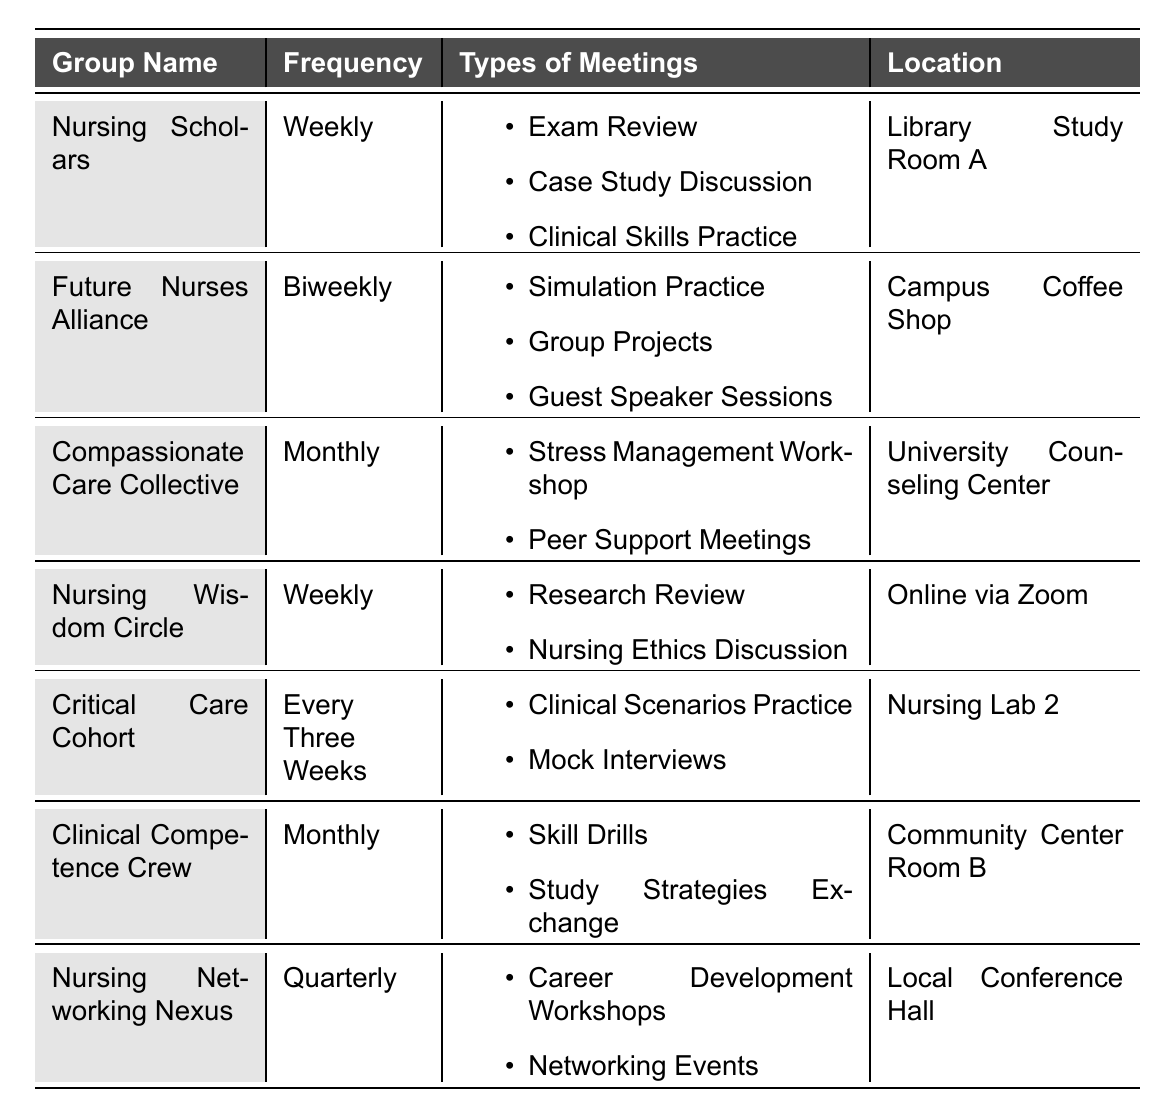What is the location of the Nursing Scholars group? The table lists "Library Study Room A" as the location for the Nursing Scholars group under the "Location" column.
Answer: Library Study Room A How often does the Clinical Competence Crew meet? The frequency column indicates that the Clinical Competence Crew has meetings "Monthly."
Answer: Monthly What types of meetings are held by the Future Nurses Alliance? Under the types of meetings for the Future Nurses Alliance, the table lists "Simulation Practice," "Group Projects," and "Guest Speaker Sessions."
Answer: Simulation Practice, Group Projects, Guest Speaker Sessions Is there any group that meets every three weeks? The table specifies that the Critical Care Cohort meets every three weeks, which confirms the existence of such a group.
Answer: Yes Which group has the highest frequency of meetings and what is it? Comparing the frequency of each group, the Nursing Scholars and Nursing Wisdom Circle both meet weekly, which is the highest frequency listed in the table.
Answer: Nursing Scholars and Nursing Wisdom Circle (Weekly) Which type of meeting is common to both the Nursing Scholars and Nursing Wisdom Circle groups? Upon reviewing the types of meetings, there are no identical types between these two groups; therefore, no common type exists.
Answer: None What are the total number of unique types of meetings held across all groups? By reviewing each group's types of meetings, the unique types are counted: Exam Review, Case Study Discussion, Clinical Skills Practice, Simulation Practice, Group Projects, Guest Speaker Sessions, Stress Management Workshop, Peer Support Meetings, Research Review, Nursing Ethics Discussion, Clinical Scenarios Practice, Mock Interviews, Skill Drills, Study Strategies Exchange, Career Development Workshops, and Networking Events, totaling 15 unique types.
Answer: 15 Which group's meetings focus primarily on stress management? The Compassionate Care Collective specifically has meetings identified as "Stress Management Workshop" and "Peer Support Meetings," focusing on stress management activities.
Answer: Compassionate Care Collective How many groups meet in person versus online? The Nursing Scholars, Future Nurses Alliance, Compassionate Care Collective, Critical Care Cohort, and Clinical Competence Crew meet in person at various locations, totaling 5 groups, while the Nursing Wisdom Circle meets online. There are 1 group online, resulting in the conclusion that there are more in-person groups.
Answer: More in-person groups (5 in-person, 1 online) Which group meets the least frequently? The Nursing Networking Nexus meets quarterly, which is less frequent than all other groups, therefore it is the group that meets the least often.
Answer: Nursing Networking Nexus 